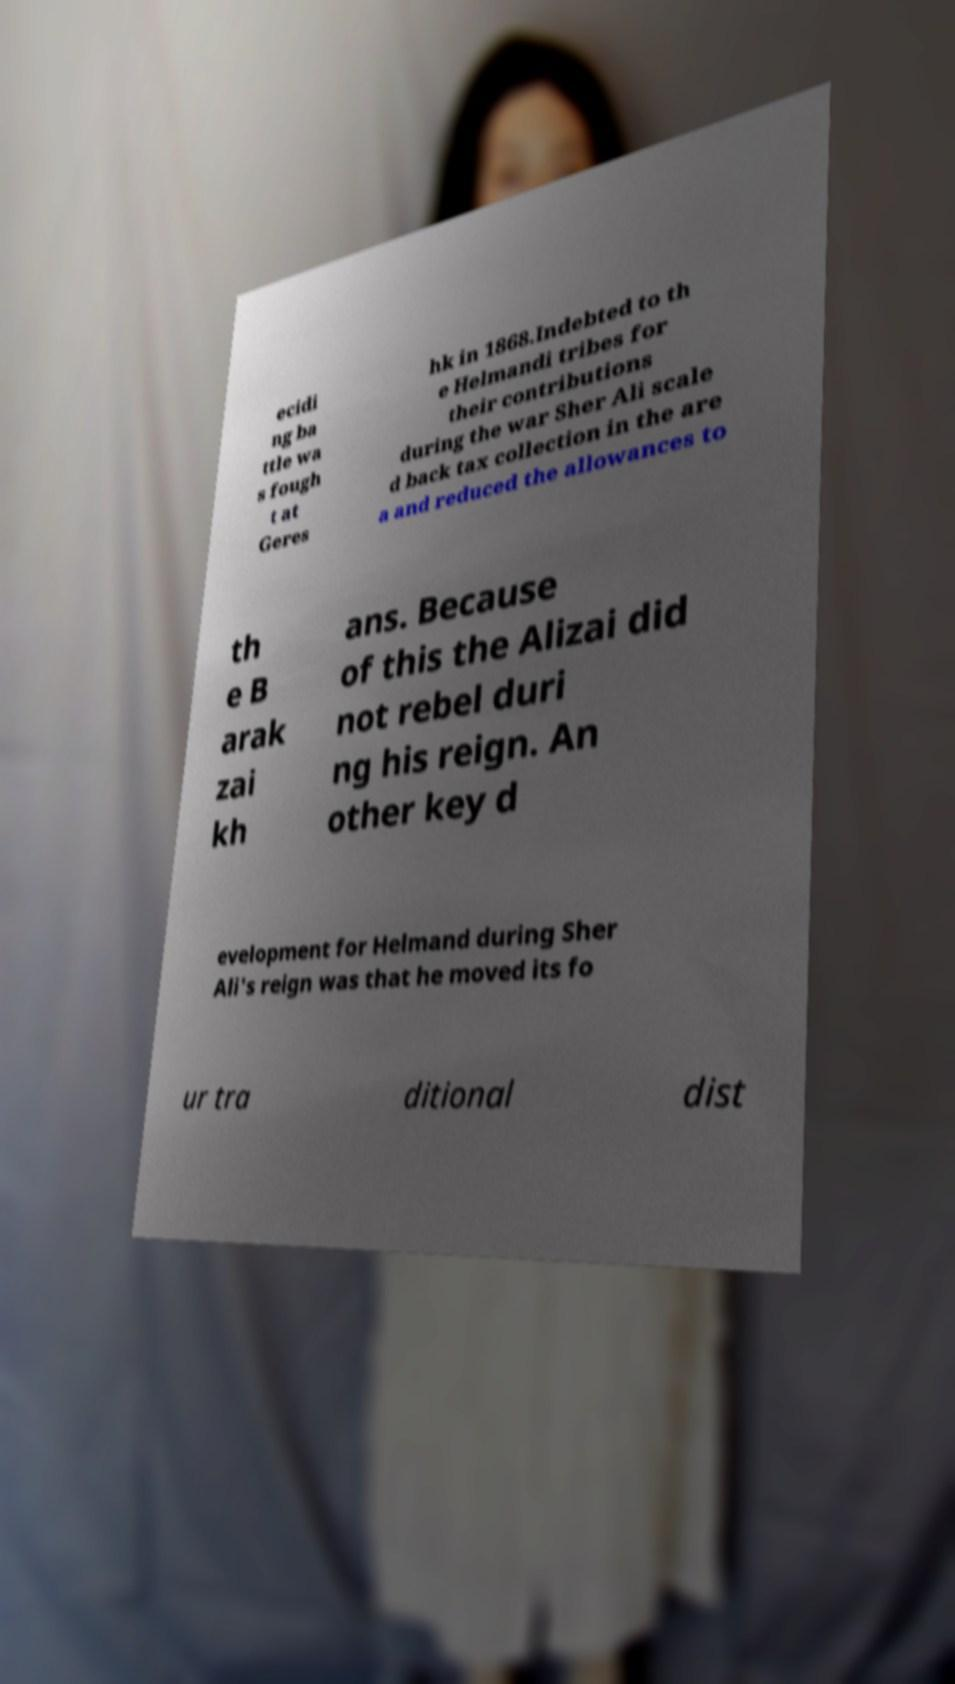Please identify and transcribe the text found in this image. ecidi ng ba ttle wa s fough t at Geres hk in 1868.Indebted to th e Helmandi tribes for their contributions during the war Sher Ali scale d back tax collection in the are a and reduced the allowances to th e B arak zai kh ans. Because of this the Alizai did not rebel duri ng his reign. An other key d evelopment for Helmand during Sher Ali's reign was that he moved its fo ur tra ditional dist 